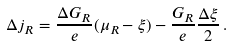Convert formula to latex. <formula><loc_0><loc_0><loc_500><loc_500>\Delta j _ { R } = \frac { \Delta G _ { R } } { e } ( \mu _ { R } - \xi ) - \frac { G _ { R } } { e } \frac { \Delta \xi } { 2 } \, .</formula> 